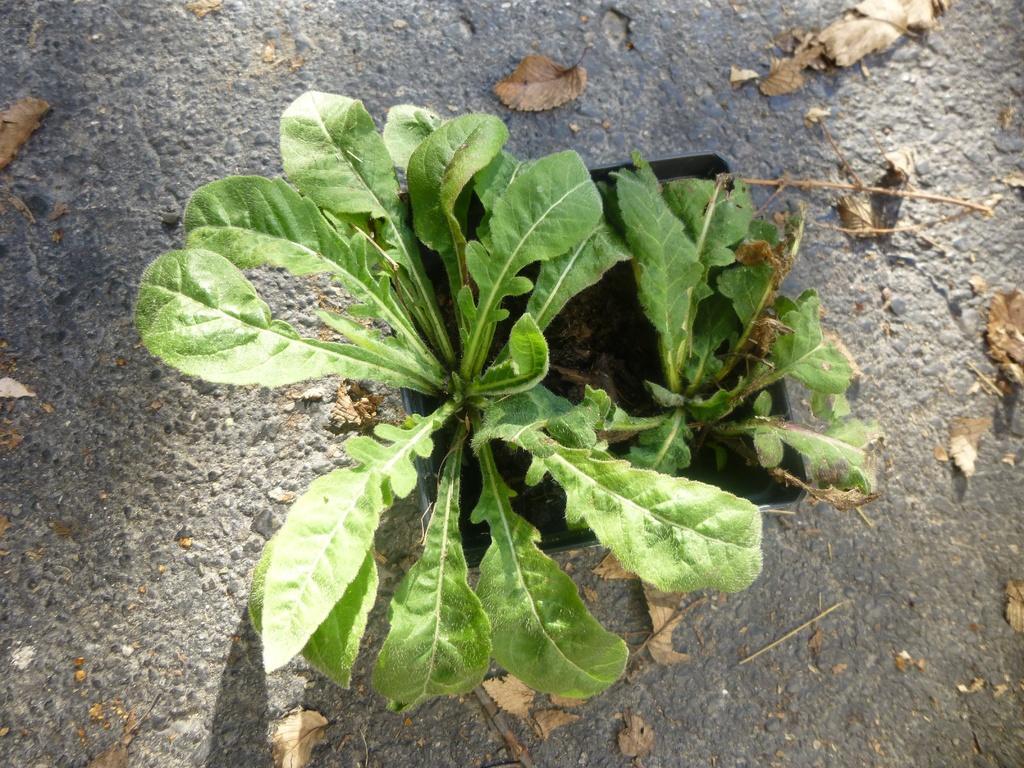Could you give a brief overview of what you see in this image? In this image I can see two plants in a pot. I can also see number of brown color leaves on the ground. 